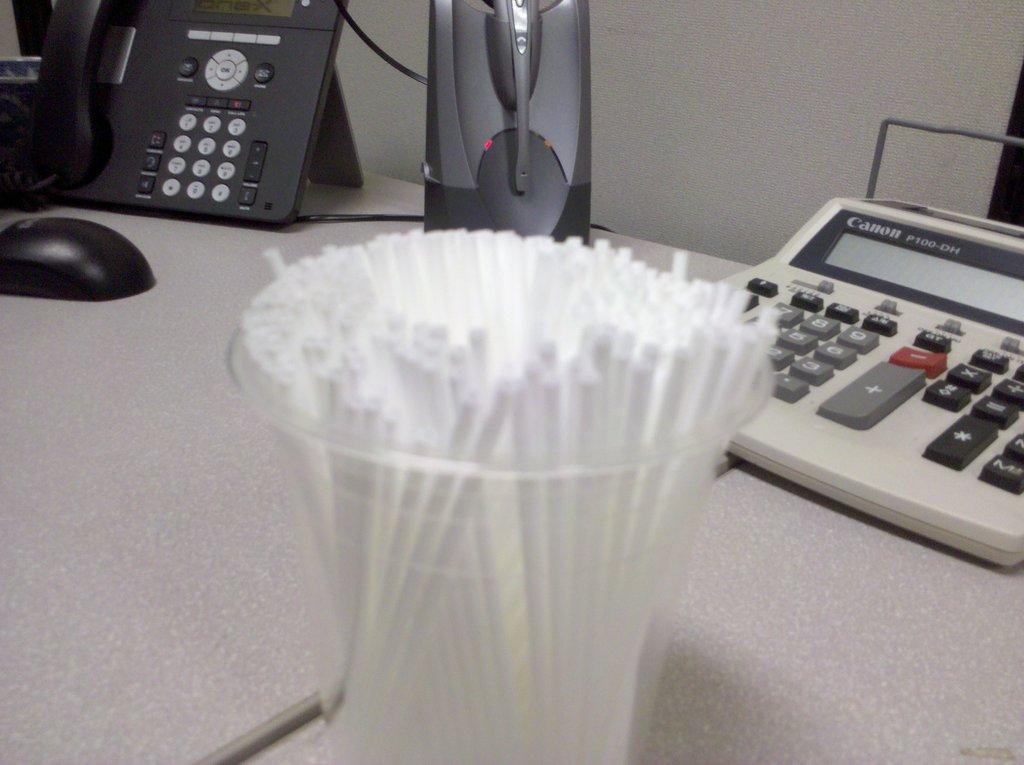<image>
Give a short and clear explanation of the subsequent image. Cup of straws in front of a calculator from Canon. 